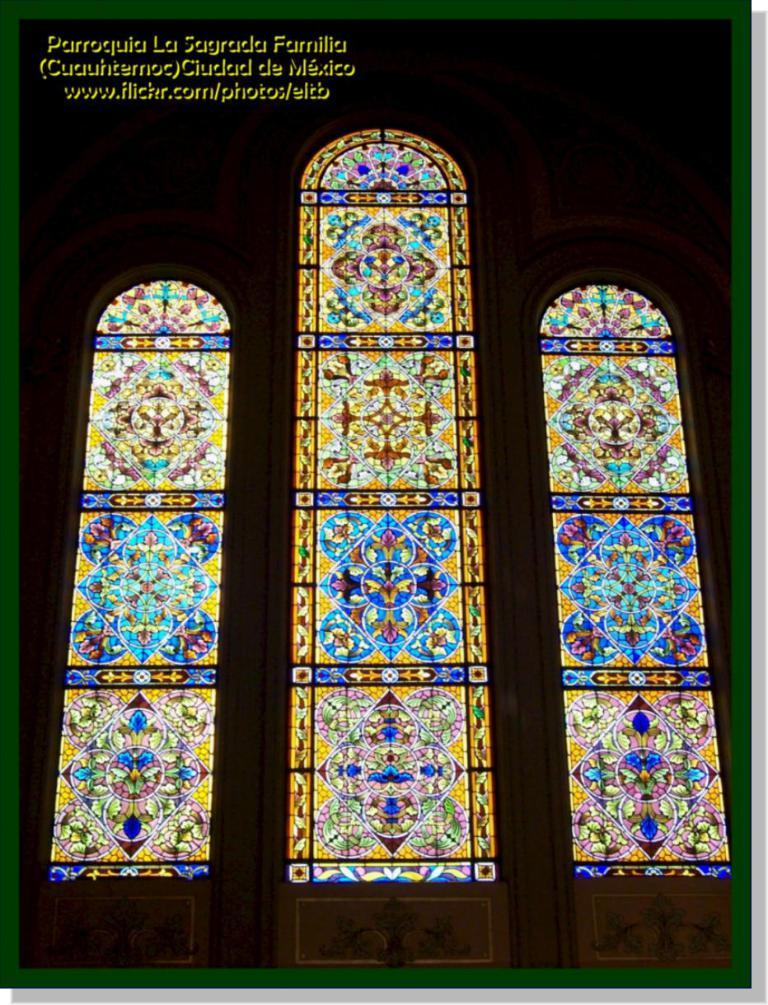How many glass windows are visible in the image? There are three glass windows in the image. What can be observed about the windows in terms of their appearance? The windows are in different colors. Is there a wound visible on any of the windows in the image? No, there is no wound present on any of the windows in the image. Can you see any flies on the windows in the image? No, there are no flies present on any of the windows in the image. 